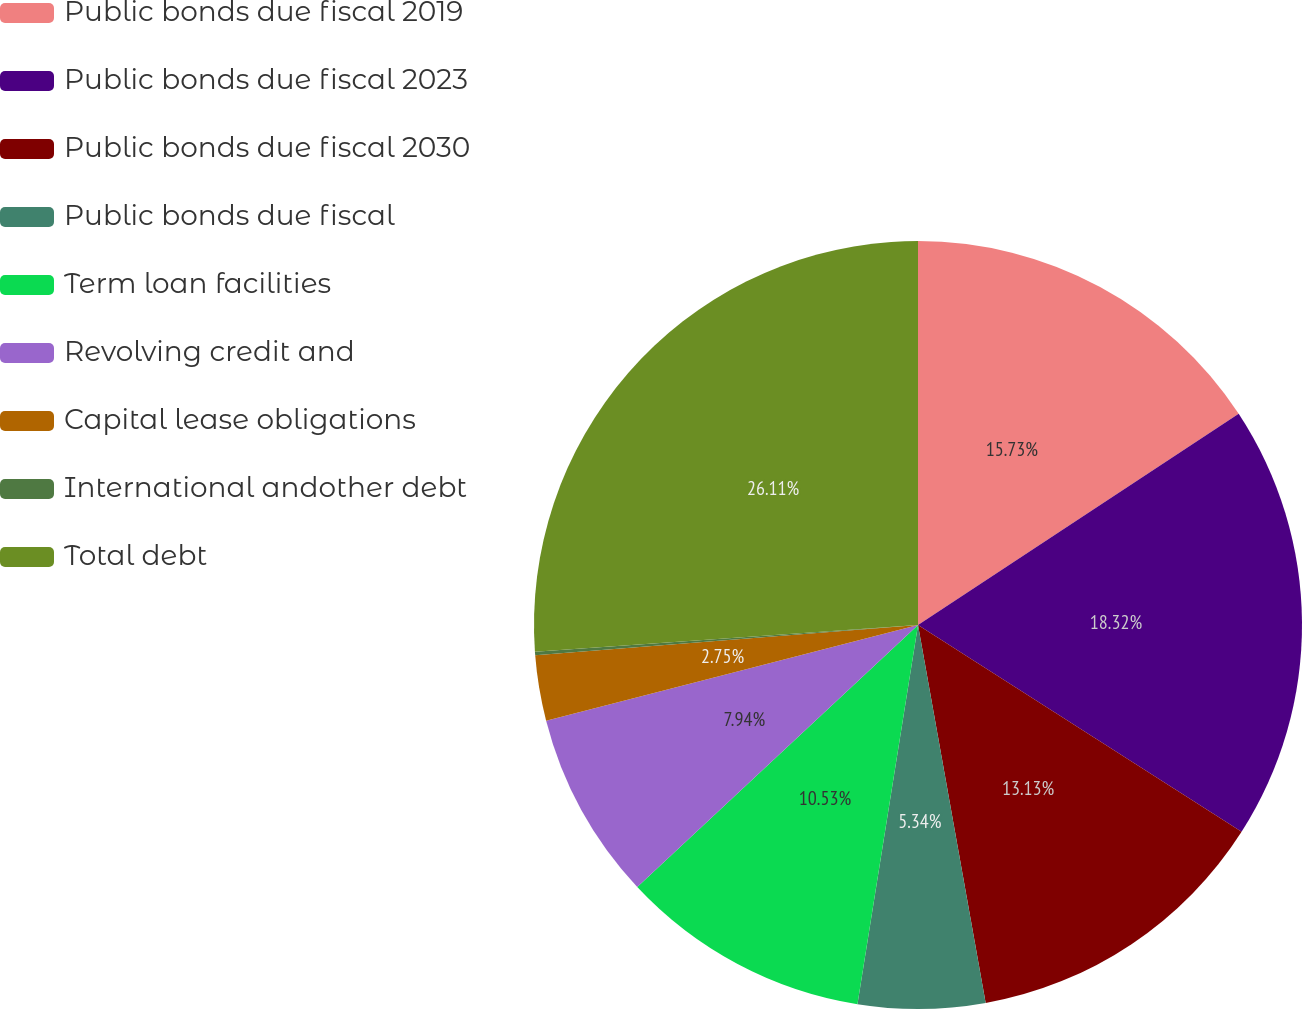<chart> <loc_0><loc_0><loc_500><loc_500><pie_chart><fcel>Public bonds due fiscal 2019<fcel>Public bonds due fiscal 2023<fcel>Public bonds due fiscal 2030<fcel>Public bonds due fiscal<fcel>Term loan facilities<fcel>Revolving credit and<fcel>Capital lease obligations<fcel>International andother debt<fcel>Total debt<nl><fcel>15.73%<fcel>18.32%<fcel>13.13%<fcel>5.34%<fcel>10.53%<fcel>7.94%<fcel>2.75%<fcel>0.15%<fcel>26.11%<nl></chart> 